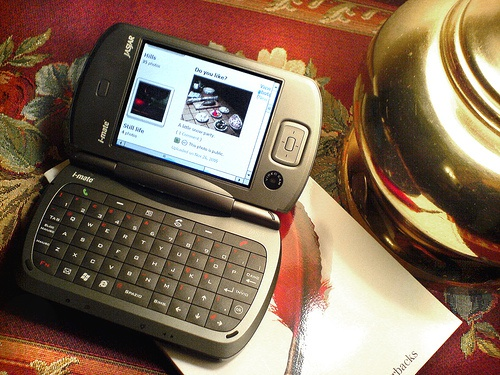Describe the objects in this image and their specific colors. I can see cell phone in maroon, black, ivory, darkgreen, and gray tones and book in maroon, ivory, tan, and salmon tones in this image. 